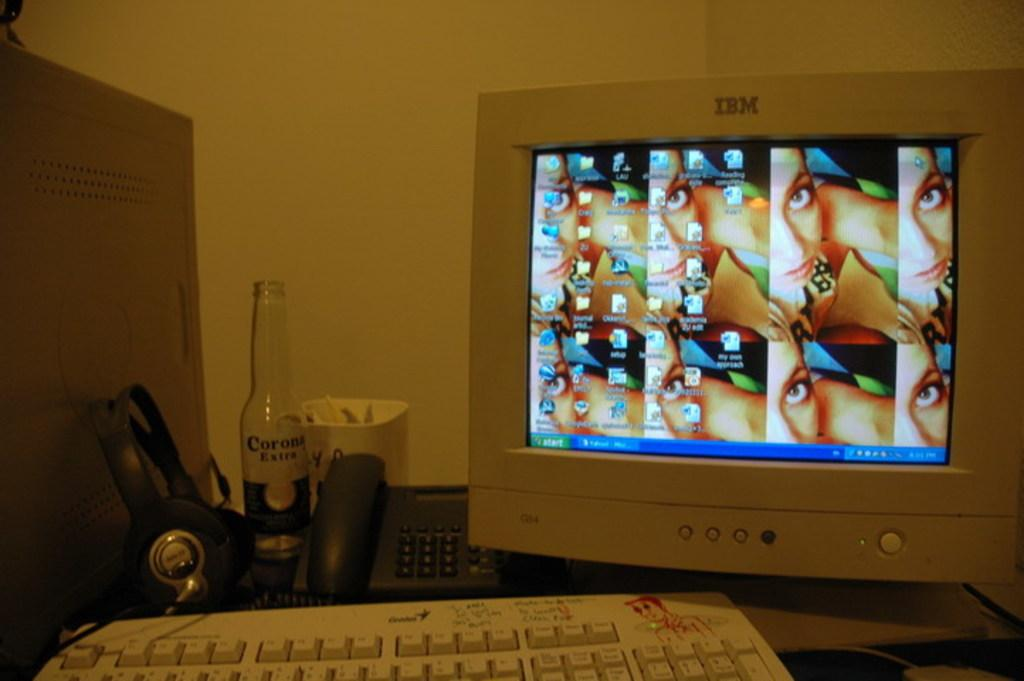Provide a one-sentence caption for the provided image. a computer that is labeled 'ibm' on it and the screen that shows the start button on it. 